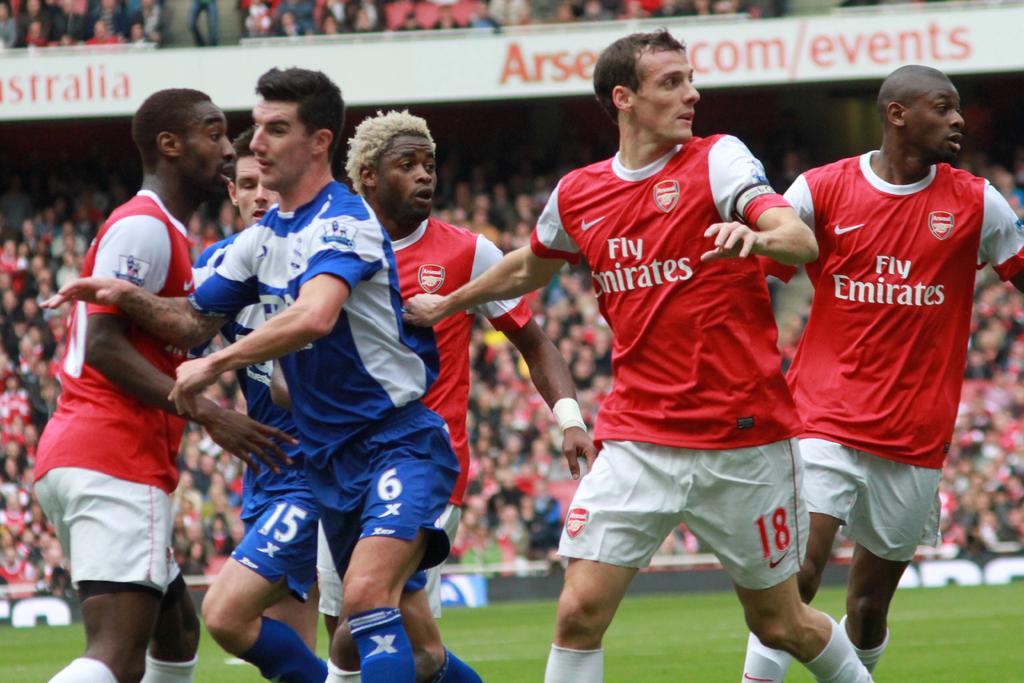What is on the red jersey?
Keep it short and to the point. Fly emirates. What number is the player in blue?
Provide a succinct answer. 6. 